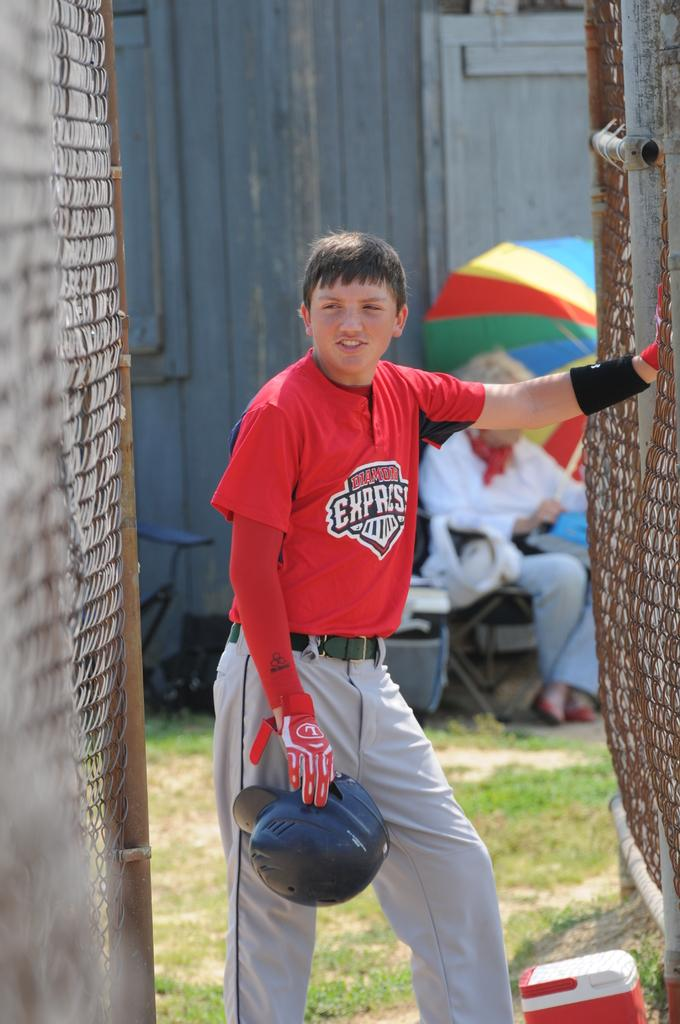<image>
Offer a succinct explanation of the picture presented. A boy wearing a Diamond Express baseball uniform is holding a batting hat. 